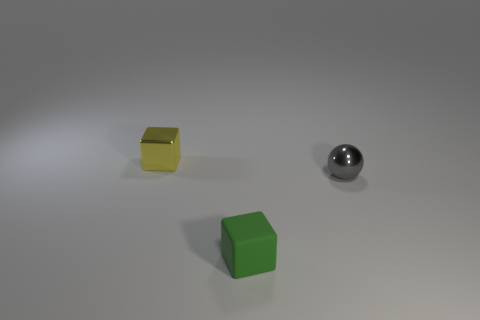What size is the block in front of the tiny thing that is to the right of the green matte cube?
Keep it short and to the point. Small. What material is the green cube that is the same size as the yellow metal block?
Give a very brief answer. Rubber. Are there any yellow things that have the same material as the tiny green thing?
Ensure brevity in your answer.  No. There is a cube that is behind the block in front of the tiny thing to the right of the tiny green rubber cube; what is its color?
Your response must be concise. Yellow. There is a metal ball behind the matte cube; does it have the same color as the small block to the left of the small matte cube?
Give a very brief answer. No. Is there any other thing of the same color as the matte object?
Ensure brevity in your answer.  No. Are there fewer metal balls that are behind the shiny ball than green matte cylinders?
Your answer should be compact. No. How many big shiny blocks are there?
Ensure brevity in your answer.  0. Is the shape of the small green object the same as the thing to the left of the tiny green thing?
Your answer should be very brief. Yes. Is the number of small metal cubes that are on the right side of the tiny yellow object less than the number of yellow metallic blocks that are in front of the rubber block?
Your answer should be compact. No. 